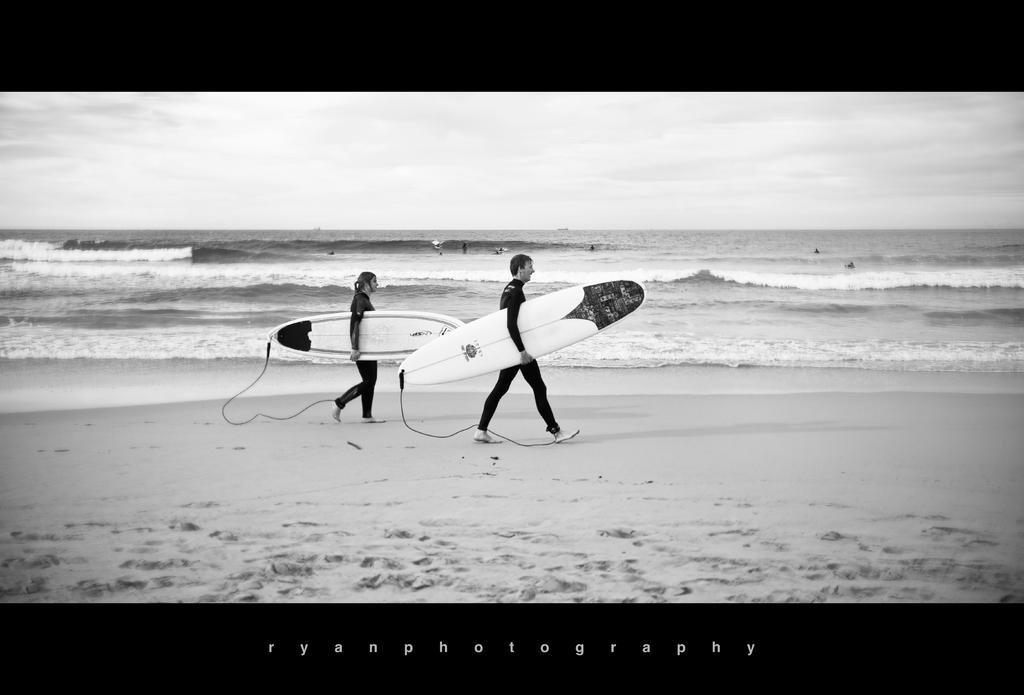How many people are the main focus of the image? There are two persons in the center of the image. What are the two persons doing in the image? The two persons are walking. What object are the two persons holding? The two persons are holding a surfboard. Can you describe the background of the image? There are additional persons visible in the background, and the sky and water are also visible. What is the condition of the sky in the image? The sky is visible in the image, and clouds are present. How many houses can be seen in the image? There are no houses visible in the image. What type of cub is playing with the cows in the image? There are no cubs or cows present in the image. 